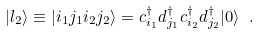<formula> <loc_0><loc_0><loc_500><loc_500>| l _ { 2 } \rangle \equiv | i _ { 1 } j _ { 1 } i _ { 2 } j _ { 2 } \rangle = c ^ { \dagger } _ { i _ { 1 } } d ^ { \dagger } _ { j _ { 1 } } c ^ { \dagger } _ { i _ { 2 } } d ^ { \dagger } _ { j _ { 2 } } | 0 \rangle \ .</formula> 